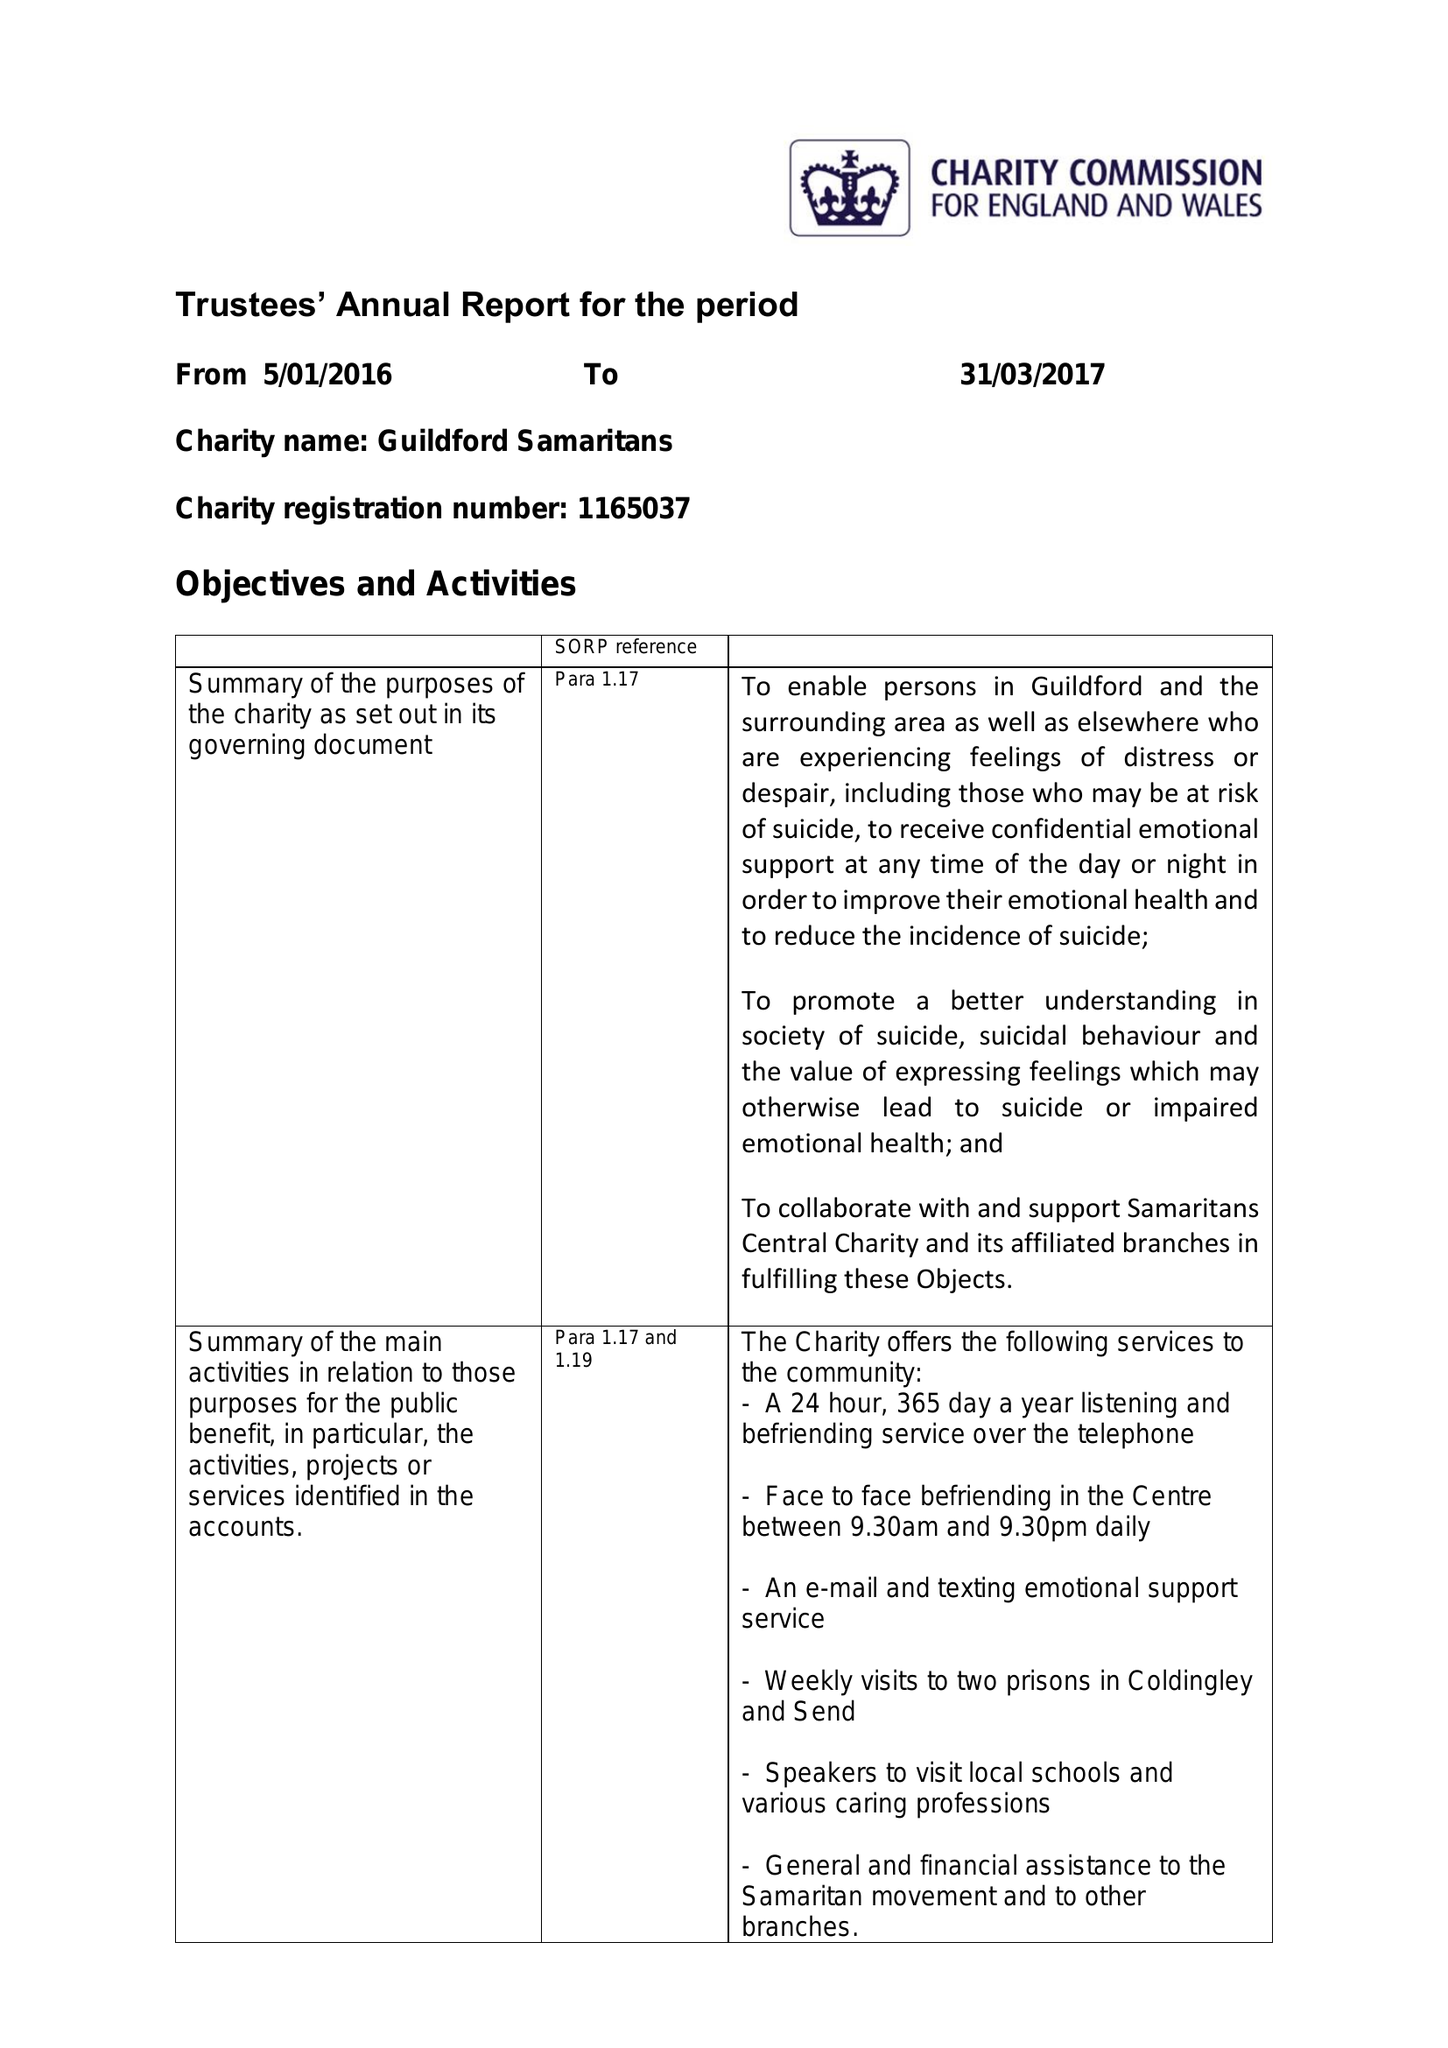What is the value for the charity_name?
Answer the question using a single word or phrase. Guildford Samaritans 